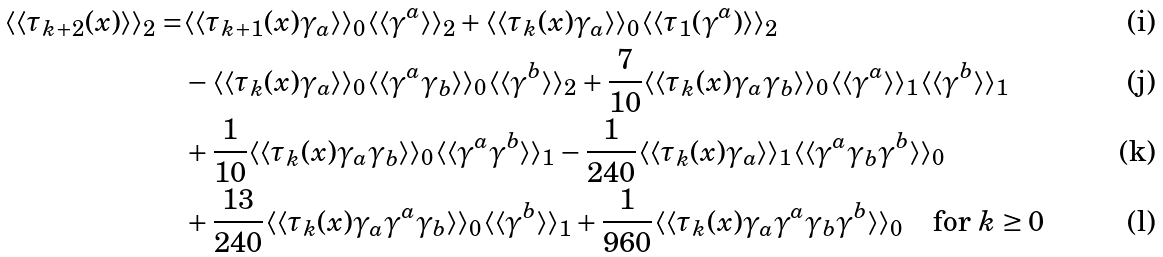Convert formula to latex. <formula><loc_0><loc_0><loc_500><loc_500>\langle \langle \tau _ { k + 2 } ( x ) \rangle \rangle _ { 2 } = & \langle \langle \tau _ { k + 1 } ( x ) \gamma _ { a } \rangle \rangle _ { 0 } \langle \langle \gamma ^ { a } \rangle \rangle _ { 2 } + \langle \langle \tau _ { k } ( x ) \gamma _ { a } \rangle \rangle _ { 0 } \langle \langle \tau _ { 1 } ( \gamma ^ { a } ) \rangle \rangle _ { 2 } \\ & - \langle \langle \tau _ { k } ( x ) \gamma _ { a } \rangle \rangle _ { 0 } \langle \langle \gamma ^ { a } \gamma _ { b } \rangle \rangle _ { 0 } \langle \langle \gamma ^ { b } \rangle \rangle _ { 2 } + \frac { 7 } { 1 0 } \langle \langle \tau _ { k } ( x ) \gamma _ { a } \gamma _ { b } \rangle \rangle _ { 0 } \langle \langle \gamma ^ { a } \rangle \rangle _ { 1 } \langle \langle \gamma ^ { b } \rangle \rangle _ { 1 } \\ & + \frac { 1 } { 1 0 } \langle \langle \tau _ { k } ( x ) \gamma _ { a } \gamma _ { b } \rangle \rangle _ { 0 } \langle \langle \gamma ^ { a } \gamma ^ { b } \rangle \rangle _ { 1 } - \frac { 1 } { 2 4 0 } \langle \langle \tau _ { k } ( x ) \gamma _ { a } \rangle \rangle _ { 1 } \langle \langle \gamma ^ { a } \gamma _ { b } \gamma ^ { b } \rangle \rangle _ { 0 } \\ & + \frac { 1 3 } { 2 4 0 } \langle \langle \tau _ { k } ( x ) \gamma _ { a } \gamma ^ { a } \gamma _ { b } \rangle \rangle _ { 0 } \langle \langle \gamma ^ { b } \rangle \rangle _ { 1 } + \frac { 1 } { 9 6 0 } \langle \langle \tau _ { k } ( x ) \gamma _ { a } \gamma ^ { a } \gamma _ { b } \gamma ^ { b } \rangle \rangle _ { 0 } \quad \text {for } k \geq 0</formula> 